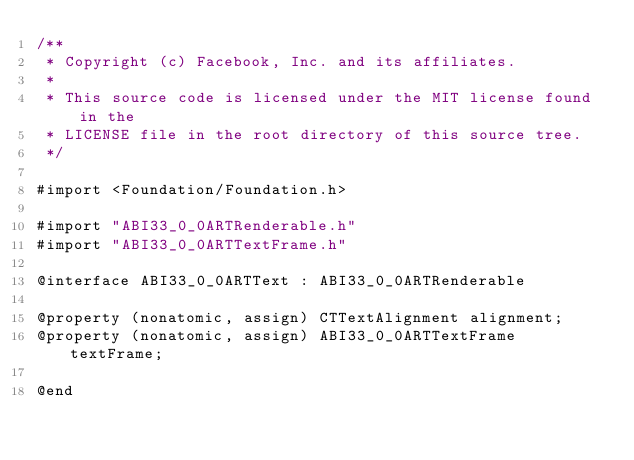<code> <loc_0><loc_0><loc_500><loc_500><_C_>/**
 * Copyright (c) Facebook, Inc. and its affiliates.
 *
 * This source code is licensed under the MIT license found in the
 * LICENSE file in the root directory of this source tree.
 */

#import <Foundation/Foundation.h>

#import "ABI33_0_0ARTRenderable.h"
#import "ABI33_0_0ARTTextFrame.h"

@interface ABI33_0_0ARTText : ABI33_0_0ARTRenderable

@property (nonatomic, assign) CTTextAlignment alignment;
@property (nonatomic, assign) ABI33_0_0ARTTextFrame textFrame;

@end
</code> 